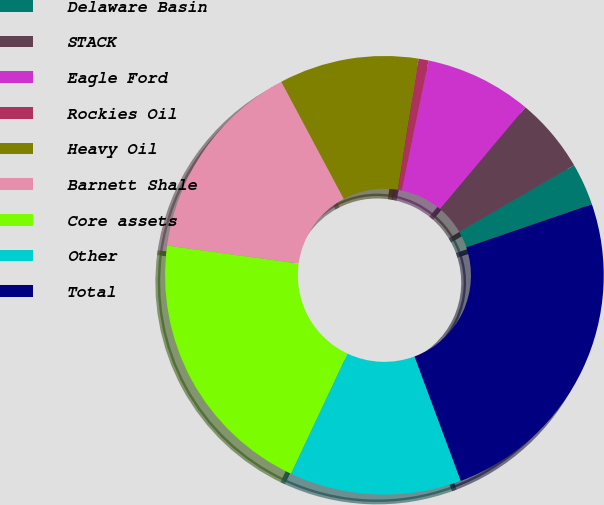Convert chart to OTSL. <chart><loc_0><loc_0><loc_500><loc_500><pie_chart><fcel>Delaware Basin<fcel>STACK<fcel>Eagle Ford<fcel>Rockies Oil<fcel>Heavy Oil<fcel>Barnett Shale<fcel>Core assets<fcel>Other<fcel>Total<nl><fcel>3.12%<fcel>5.51%<fcel>7.89%<fcel>0.74%<fcel>10.28%<fcel>15.05%<fcel>20.16%<fcel>12.66%<fcel>24.59%<nl></chart> 